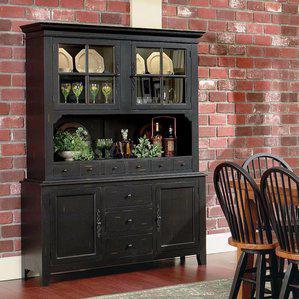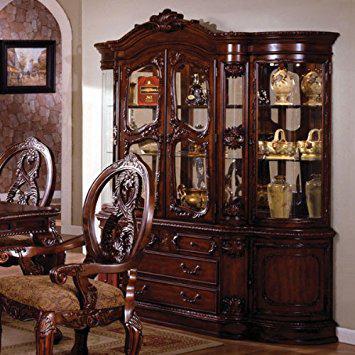The first image is the image on the left, the second image is the image on the right. Evaluate the accuracy of this statement regarding the images: "There is at least one chair in every image.". Is it true? Answer yes or no. Yes. The first image is the image on the left, the second image is the image on the right. For the images shown, is this caption "A richly-colored brown cabinet has an arch shape at the center of the top and sits flush on the floor." true? Answer yes or no. Yes. 